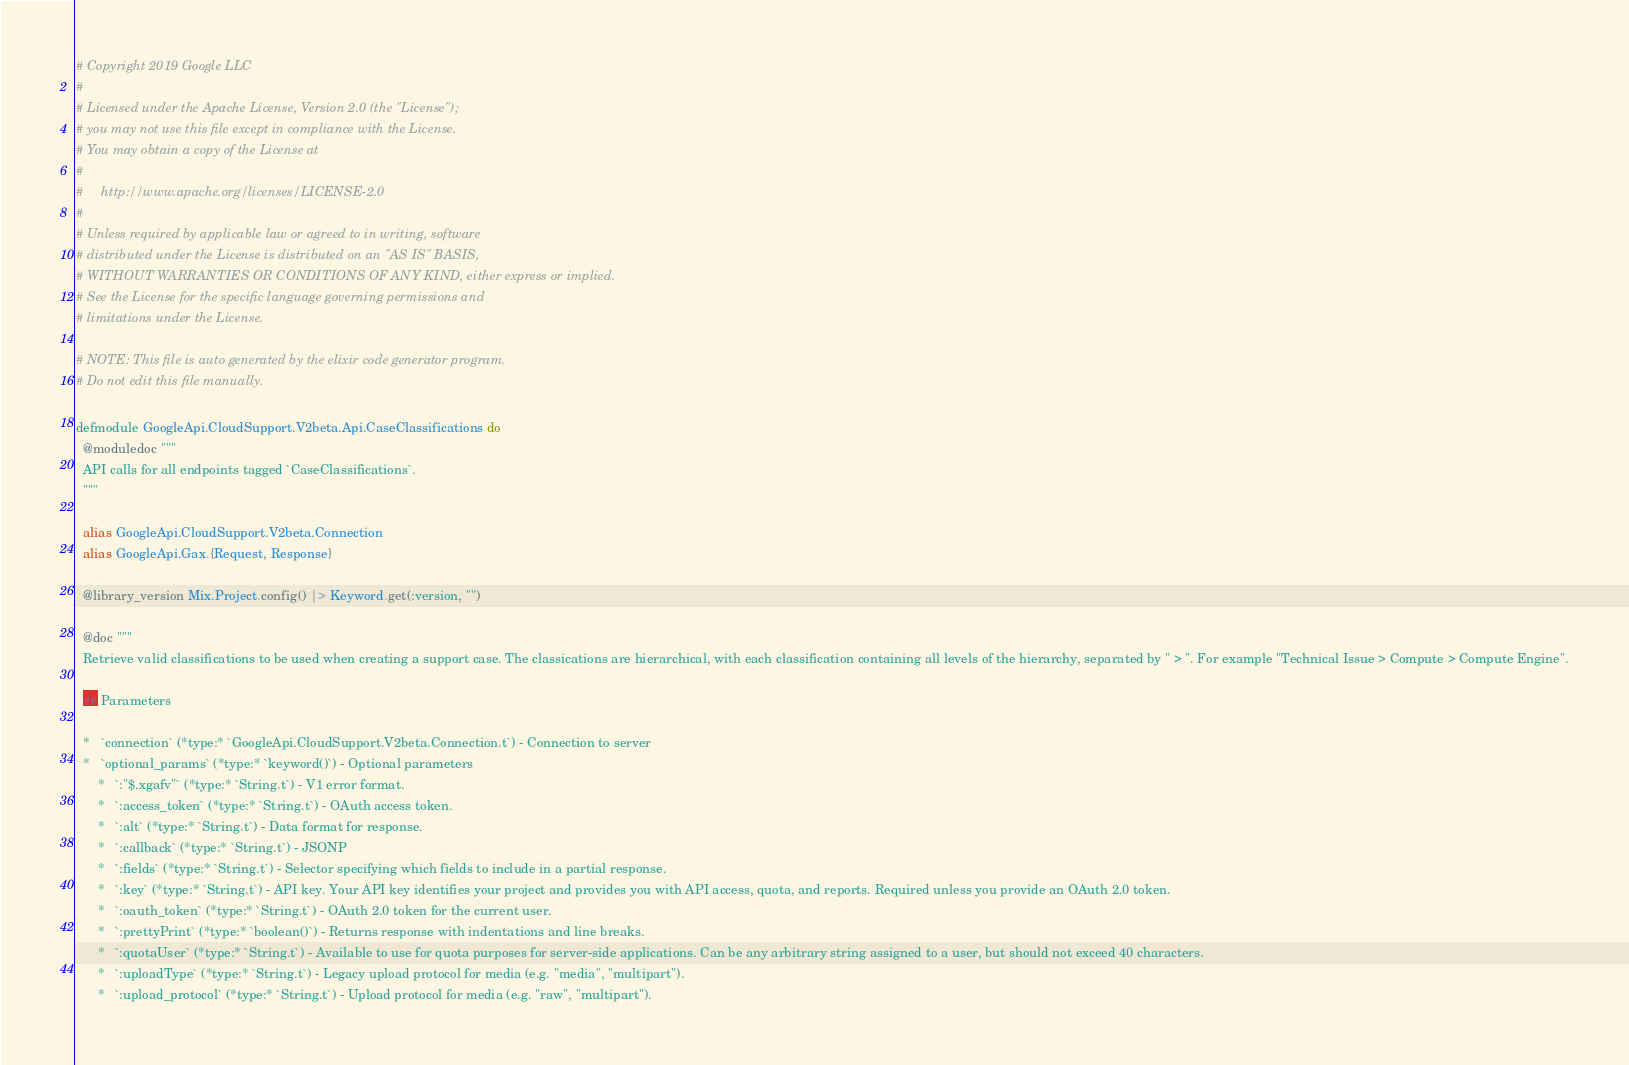<code> <loc_0><loc_0><loc_500><loc_500><_Elixir_># Copyright 2019 Google LLC
#
# Licensed under the Apache License, Version 2.0 (the "License");
# you may not use this file except in compliance with the License.
# You may obtain a copy of the License at
#
#     http://www.apache.org/licenses/LICENSE-2.0
#
# Unless required by applicable law or agreed to in writing, software
# distributed under the License is distributed on an "AS IS" BASIS,
# WITHOUT WARRANTIES OR CONDITIONS OF ANY KIND, either express or implied.
# See the License for the specific language governing permissions and
# limitations under the License.

# NOTE: This file is auto generated by the elixir code generator program.
# Do not edit this file manually.

defmodule GoogleApi.CloudSupport.V2beta.Api.CaseClassifications do
  @moduledoc """
  API calls for all endpoints tagged `CaseClassifications`.
  """

  alias GoogleApi.CloudSupport.V2beta.Connection
  alias GoogleApi.Gax.{Request, Response}

  @library_version Mix.Project.config() |> Keyword.get(:version, "")

  @doc """
  Retrieve valid classifications to be used when creating a support case. The classications are hierarchical, with each classification containing all levels of the hierarchy, separated by " > ". For example "Technical Issue > Compute > Compute Engine".

  ## Parameters

  *   `connection` (*type:* `GoogleApi.CloudSupport.V2beta.Connection.t`) - Connection to server
  *   `optional_params` (*type:* `keyword()`) - Optional parameters
      *   `:"$.xgafv"` (*type:* `String.t`) - V1 error format.
      *   `:access_token` (*type:* `String.t`) - OAuth access token.
      *   `:alt` (*type:* `String.t`) - Data format for response.
      *   `:callback` (*type:* `String.t`) - JSONP
      *   `:fields` (*type:* `String.t`) - Selector specifying which fields to include in a partial response.
      *   `:key` (*type:* `String.t`) - API key. Your API key identifies your project and provides you with API access, quota, and reports. Required unless you provide an OAuth 2.0 token.
      *   `:oauth_token` (*type:* `String.t`) - OAuth 2.0 token for the current user.
      *   `:prettyPrint` (*type:* `boolean()`) - Returns response with indentations and line breaks.
      *   `:quotaUser` (*type:* `String.t`) - Available to use for quota purposes for server-side applications. Can be any arbitrary string assigned to a user, but should not exceed 40 characters.
      *   `:uploadType` (*type:* `String.t`) - Legacy upload protocol for media (e.g. "media", "multipart").
      *   `:upload_protocol` (*type:* `String.t`) - Upload protocol for media (e.g. "raw", "multipart").</code> 